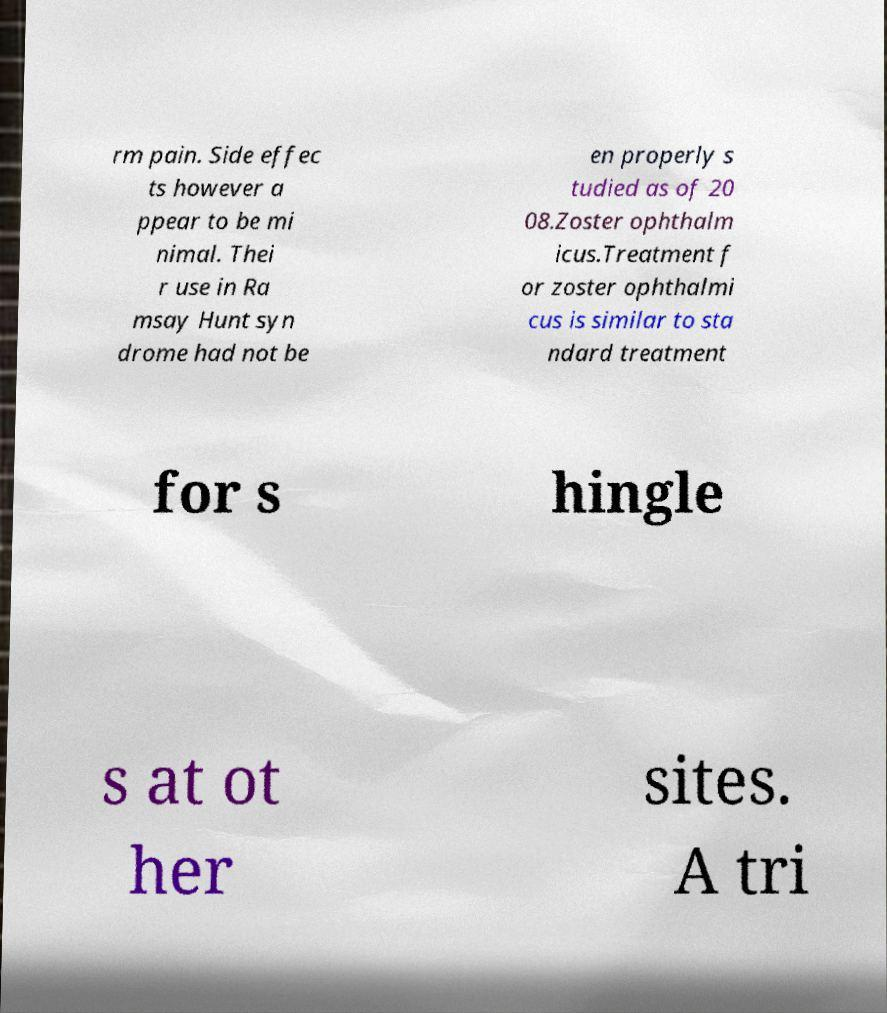There's text embedded in this image that I need extracted. Can you transcribe it verbatim? rm pain. Side effec ts however a ppear to be mi nimal. Thei r use in Ra msay Hunt syn drome had not be en properly s tudied as of 20 08.Zoster ophthalm icus.Treatment f or zoster ophthalmi cus is similar to sta ndard treatment for s hingle s at ot her sites. A tri 